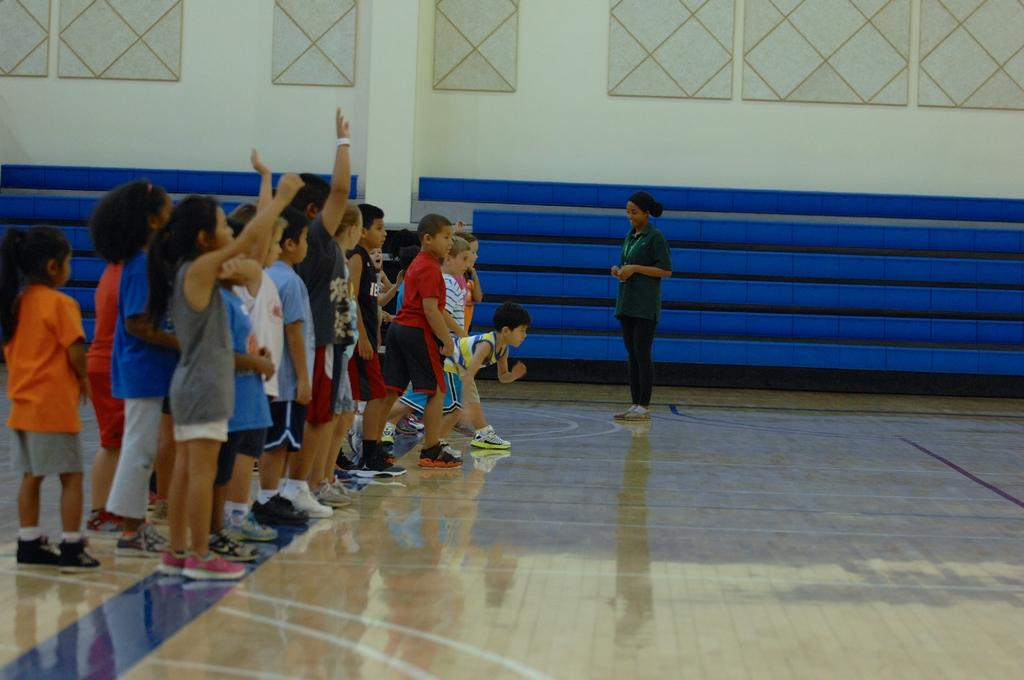How many people are in the image? There is a group of persons in the image, but the exact number is not specified. What are the persons in the image doing? The persons are on the ground, but their specific activity is not mentioned. What can be seen in the background of the image? There is a wall in the background of the image. What type of cap is the store selling in the image? There is no store or cap present in the image. What color is the powder that the persons are using in the image? There is no powder or activity involving powder in the image. 